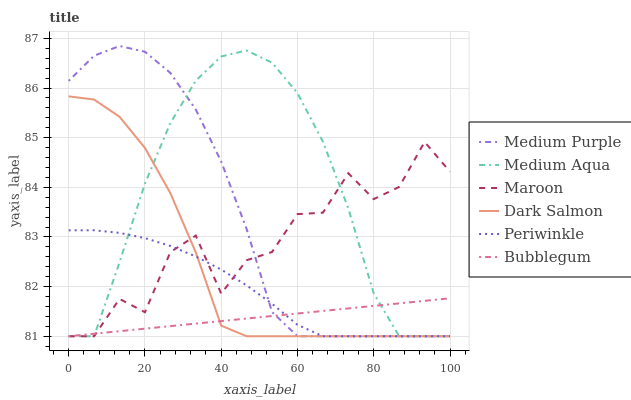Does Medium Purple have the minimum area under the curve?
Answer yes or no. No. Does Medium Purple have the maximum area under the curve?
Answer yes or no. No. Is Medium Purple the smoothest?
Answer yes or no. No. Is Medium Purple the roughest?
Answer yes or no. No. Does Bubblegum have the highest value?
Answer yes or no. No. 